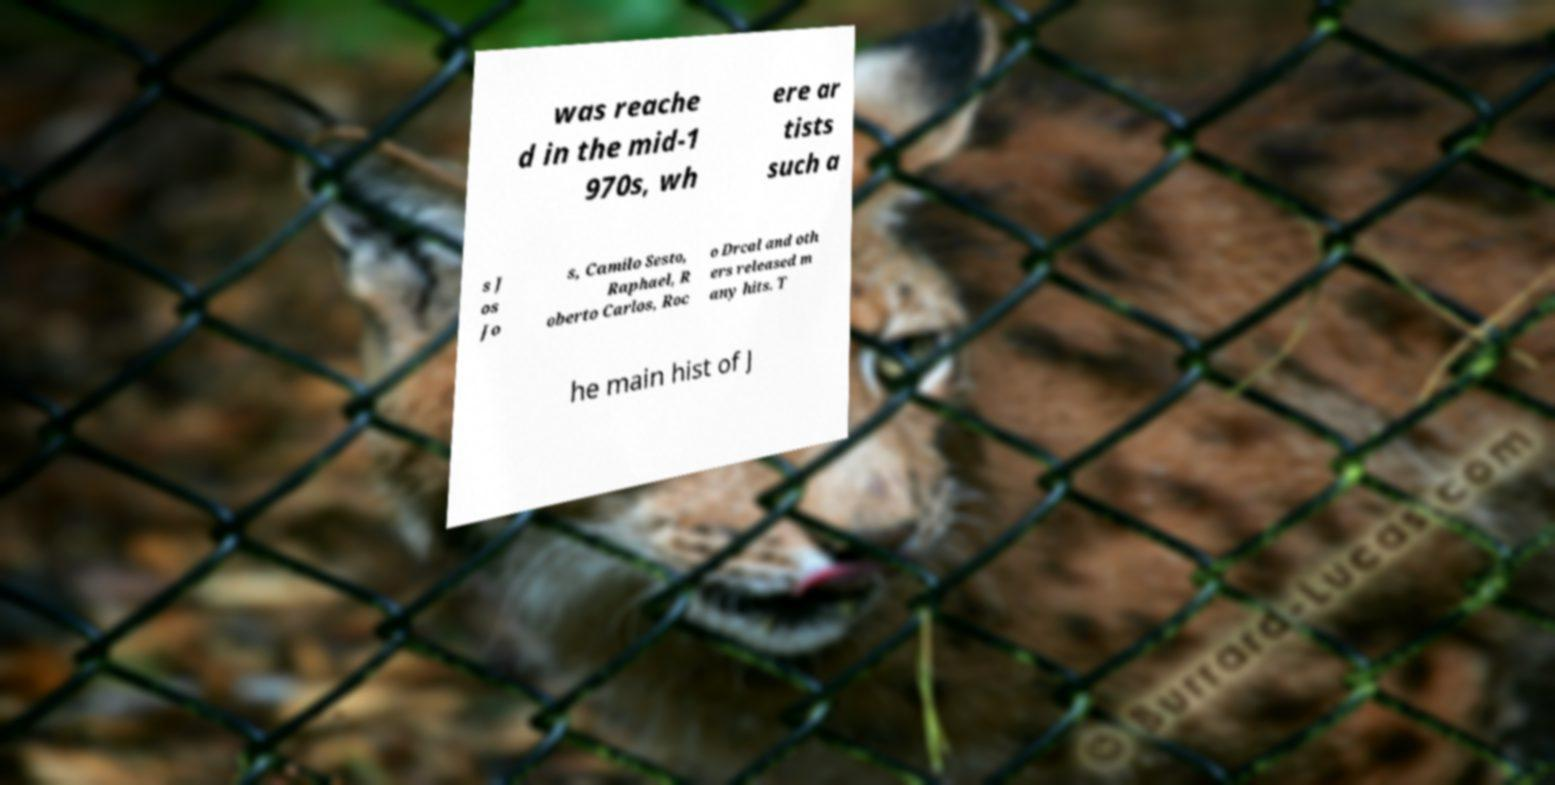For documentation purposes, I need the text within this image transcribed. Could you provide that? was reache d in the mid-1 970s, wh ere ar tists such a s J os Jo s, Camilo Sesto, Raphael, R oberto Carlos, Roc o Drcal and oth ers released m any hits. T he main hist of J 